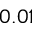Convert formula to latex. <formula><loc_0><loc_0><loc_500><loc_500>0 . 0 1</formula> 